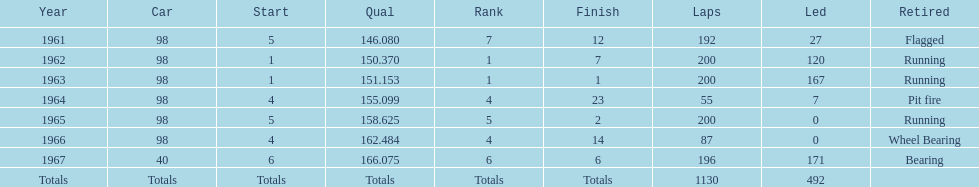What car ranked #1 from 1962-1963? 98. Would you mind parsing the complete table? {'header': ['Year', 'Car', 'Start', 'Qual', 'Rank', 'Finish', 'Laps', 'Led', 'Retired'], 'rows': [['1961', '98', '5', '146.080', '7', '12', '192', '27', 'Flagged'], ['1962', '98', '1', '150.370', '1', '7', '200', '120', 'Running'], ['1963', '98', '1', '151.153', '1', '1', '200', '167', 'Running'], ['1964', '98', '4', '155.099', '4', '23', '55', '7', 'Pit fire'], ['1965', '98', '5', '158.625', '5', '2', '200', '0', 'Running'], ['1966', '98', '4', '162.484', '4', '14', '87', '0', 'Wheel Bearing'], ['1967', '40', '6', '166.075', '6', '6', '196', '171', 'Bearing'], ['Totals', 'Totals', 'Totals', 'Totals', 'Totals', 'Totals', '1130', '492', '']]} 